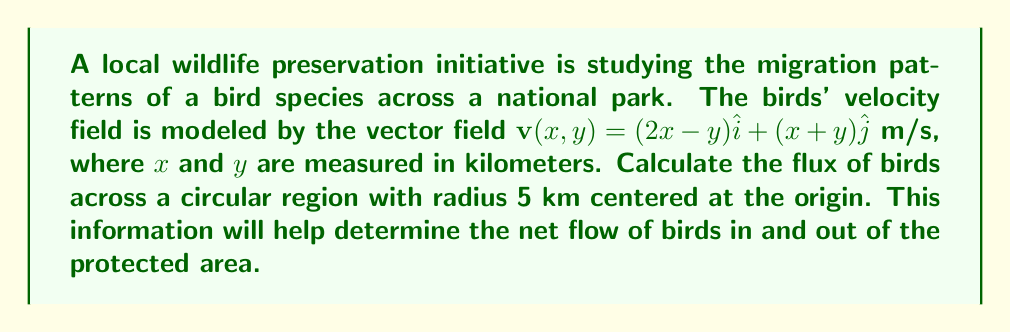Solve this math problem. To solve this problem, we'll use the divergence theorem from vector calculus, which relates the flux across a closed surface to the divergence of the vector field within the volume enclosed by the surface.

Step 1: Calculate the divergence of the velocity field.
$$\nabla \cdot \mathbf{v} = \frac{\partial}{\partial x}(2x-y) + \frac{\partial}{\partial y}(x+y) = 2 + 1 = 3$$

Step 2: Set up the divergence theorem.
The divergence theorem states:
$$\iint_S \mathbf{v} \cdot \mathbf{n} \, dS = \iiint_V \nabla \cdot \mathbf{v} \, dV$$
where $S$ is the surface of the region and $V$ is the volume enclosed.

Step 3: Calculate the volume integral.
Since the divergence is constant, we can simplify the volume integral:
$$\iiint_V \nabla \cdot \mathbf{v} \, dV = 3 \cdot \text{Area of circle}$$
$$= 3 \cdot \pi r^2 = 3 \cdot \pi \cdot 5^2 = 75\pi$$

Step 4: Interpret the result.
The flux of 75π m²/s represents the net rate at which birds are leaving the circular region. A positive flux indicates a net outflow of birds from the protected area.
Answer: 75π m²/s (outward flux) 